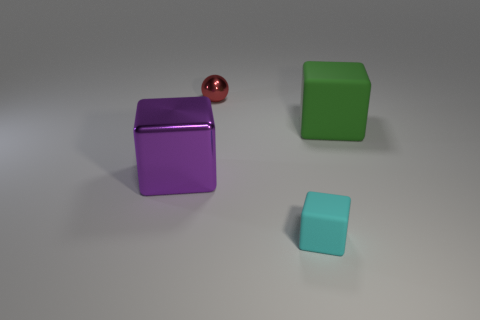Add 1 brown metallic cubes. How many objects exist? 5 Add 4 tiny cyan matte cylinders. How many tiny cyan matte cylinders exist? 4 Subtract 0 yellow spheres. How many objects are left? 4 Subtract all spheres. How many objects are left? 3 Subtract all purple things. Subtract all large purple blocks. How many objects are left? 2 Add 1 green cubes. How many green cubes are left? 2 